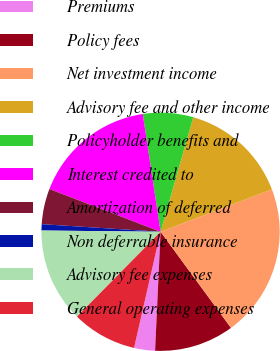Convert chart to OTSL. <chart><loc_0><loc_0><loc_500><loc_500><pie_chart><fcel>Premiums<fcel>Policy fees<fcel>Net investment income<fcel>Advisory fee and other income<fcel>Policyholder benefits and<fcel>Interest credited to<fcel>Amortization of deferred<fcel>Non deferrable insurance<fcel>Advisory fee expenses<fcel>General operating expenses<nl><fcel>2.84%<fcel>10.8%<fcel>20.74%<fcel>14.78%<fcel>6.82%<fcel>16.77%<fcel>4.83%<fcel>0.85%<fcel>12.79%<fcel>8.81%<nl></chart> 